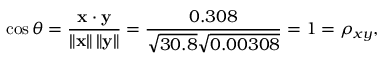<formula> <loc_0><loc_0><loc_500><loc_500>\cos \theta = { \frac { x \cdot y } { \left \| x \right \| \left \| y \right \| } } = { \frac { 0 . 3 0 8 } { { \sqrt { 3 0 . 8 } } { \sqrt { 0 . 0 0 3 0 8 } } } } = 1 = \rho _ { x y } ,</formula> 